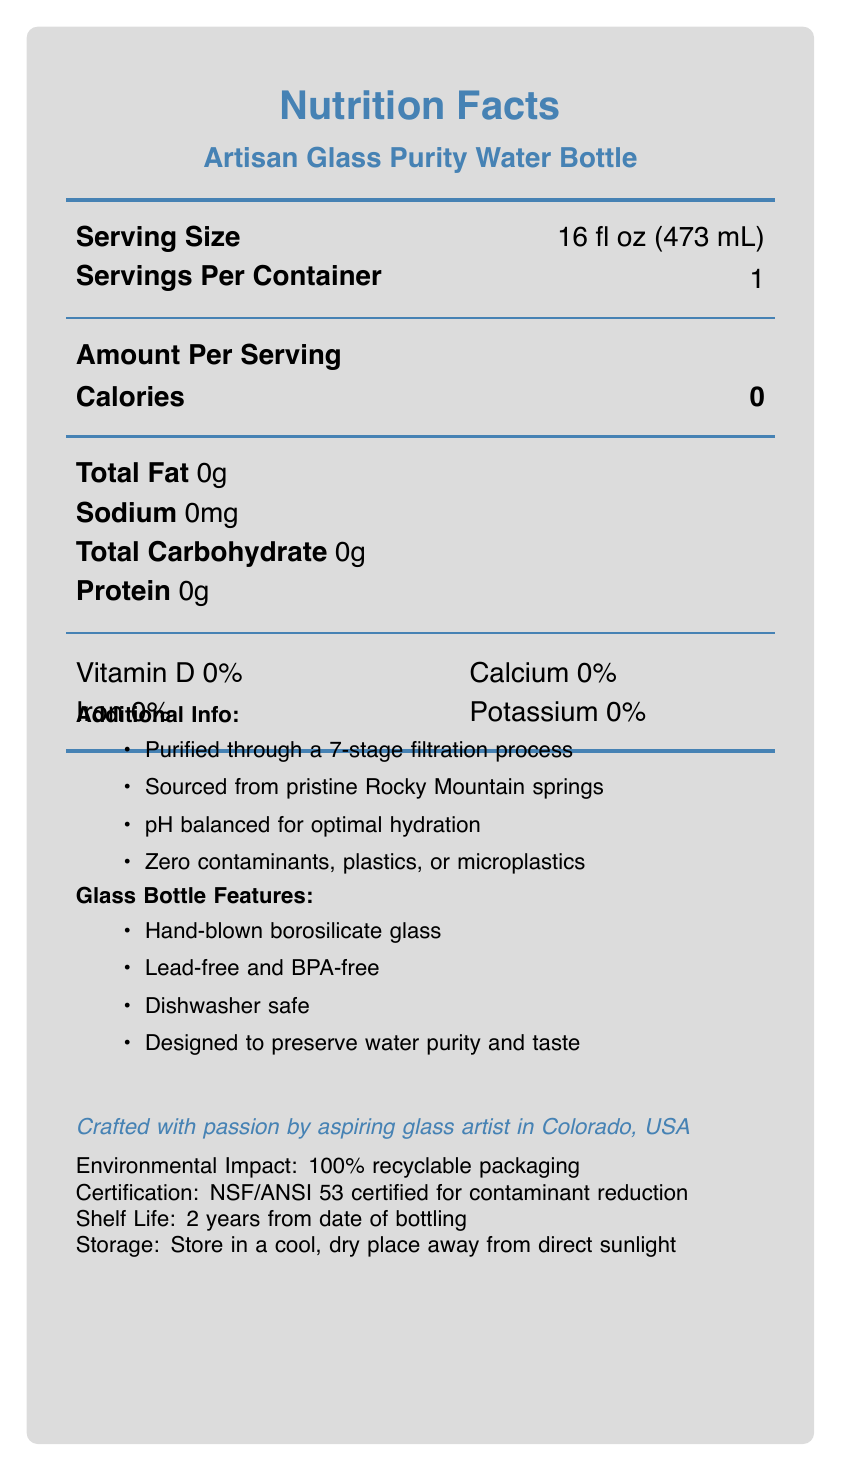what is the serving size of the Artisan Glass Purity Water Bottle? The serving size is clearly listed as 16 fl oz (473 mL) on the nutrition facts label.
Answer: 16 fl oz (473 mL) how many servings are there per container? The document indicates that there is one serving per container.
Answer: 1 how many calories are in the Artisan Glass Purity Water Bottle? The nutrition facts label shows that the water bottle contains 0 calories per serving.
Answer: 0 what is the total fat content per serving? The document states that the total fat content per serving is 0 grams.
Answer: 0g does the Artisan Glass Purity Water Bottle contain any sodium? The nutrition facts label shows that the bottle contains 0mg of sodium, indicating no sodium content.
Answer: No what are some trace minerals present in the Artisan Glass Purity Water Bottle? The trace minerals listed in the document are Calcium (<1mg), Magnesium (<1mg), and Potassium (<1mg).
Answer: Calcium, Magnesium, and Potassium which of the following certifications does the Artisan Glass Purity Water Bottle have? A. ISO 9001 B. NSF/ANSI 53 C. EPA D. FDA The document mentions that the bottle is NSF/ANSI 53 certified for contaminant reduction.
Answer: B. NSF/ANSI 53 the glass bottle is made from: A. Quartz glass B. Hand-blown borosilicate glass C. Recycled glass D. Crystal glass Under the Glass Bottle Features section, it states that the bottle is made from hand-blown borosilicate glass.
Answer: B. Hand-blown borosilicate glass is the Artisan Glass Purity Water Bottle dishwasher safe? The Glass Bottle Features section mentions that the bottle is dishwasher safe.
Answer: Yes describe the main features and content information provided for the Artisan Glass Purity Water Bottle The document details the water bottle’s nutrition facts, emphasizing zero calories and major nutrients, the source and purity of the water, the specially designed glass bottle features, its certification, and eco-friendly attributes.
Answer: The Artisan Glass Purity Water Bottle, handcrafted by an aspiring glass artist in Colorado, USA, offers 16 fl oz (473 mL) of pure water sourced from Rocky Mountain springs, purified through a 7-stage process, and balanced for optimal hydration. The glass bottle, made from hand-blown borosilicate glass, is lead-free, BPA-free, and designed to preserve water purity and taste. The product emphasizes zero calories, fats, proteins, sodium, carbohydrates, and vitamins, with trace minerals present in minimal amounts. It boasts several certifications, a long shelf life, and eco-friendly packaging. what is the main reason the Artisan Glass Purity Water Bottle boasts no contaminants, plastics, or microplastics? The Additional Info section explains that the water is purified through a 7-stage filtration process, ensuring it is free from contaminants, plastics, or microplastics.
Answer: Purified through a 7-stage filtration process what is the shelf life of the Artisan Glass Purity Water Bottle? The document states that the shelf life of the water bottle is 2 years from the date of bottling.
Answer: 2 years from date of bottling who is the Artisan Glass Purity Water Bottle crafted by? An artisan note in the document mentions that the bottle is crafted by an aspiring glass artist in Colorado, USA.
Answer: An aspiring glass artist in Colorado, USA what is the pH level of the water in the Artisan Glass Purity Water Bottle? The document does mention that the water is pH balanced for optimal hydration but does not provide the exact pH level.
Answer: I don't know is the packaging of the Artisan Glass Purity Water Bottle recyclable? The Environmental Impact section confirms that the packaging is 100% recyclable.
Answer: Yes 